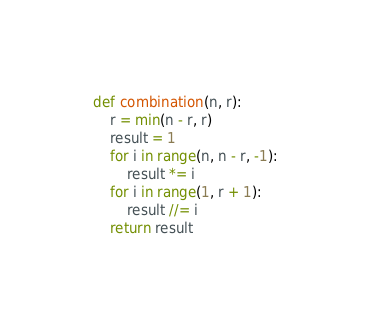<code> <loc_0><loc_0><loc_500><loc_500><_Python_>def combination(n, r):
    r = min(n - r, r)
    result = 1
    for i in range(n, n - r, -1):
        result *= i
    for i in range(1, r + 1):
        result //= i
    return result

</code> 